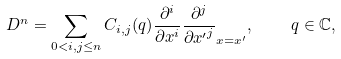<formula> <loc_0><loc_0><loc_500><loc_500>D ^ { n } = \sum _ { 0 < i , j \leq n } C _ { i , j } ( q ) \frac { \partial ^ { i } } { \partial x ^ { i } } \frac { \partial ^ { j } } { \partial { x ^ { \prime } } ^ { j } } _ { x = x ^ { \prime } } , \quad q \in \mathbb { C } ,</formula> 